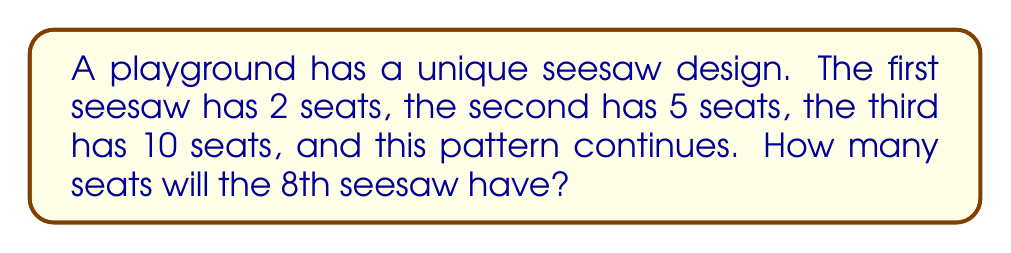What is the answer to this math problem? Let's approach this step-by-step:

1) First, let's write out the sequence for the first few terms:
   2, 5, 10, ...

2) To find the pattern, let's calculate the differences between consecutive terms:
   5 - 2 = 3
   10 - 5 = 5

3) We can see that the difference is increasing by 2 each time. This suggests a quadratic sequence.

4) The general form of a quadratic sequence is:
   $$a_n = an^2 + bn + c$$
   where $a_n$ is the nth term, and $a$, $b$, and $c$ are constants.

5) We can use the first three terms to set up a system of equations:
   $$2 = a(1)^2 + b(1) + c$$
   $$5 = a(2)^2 + b(2) + c$$
   $$10 = a(3)^2 + b(3) + c$$

6) Solving this system (which is a bit complex for this explanation), we get:
   $$a = 1, b = 0, c = 1$$

7) Therefore, our sequence follows the formula:
   $$a_n = n^2 + 1$$

8) For the 8th seesaw, we need to find $a_8$:
   $$a_8 = 8^2 + 1 = 64 + 1 = 65$$

Thus, the 8th seesaw will have 65 seats.
Answer: 65 